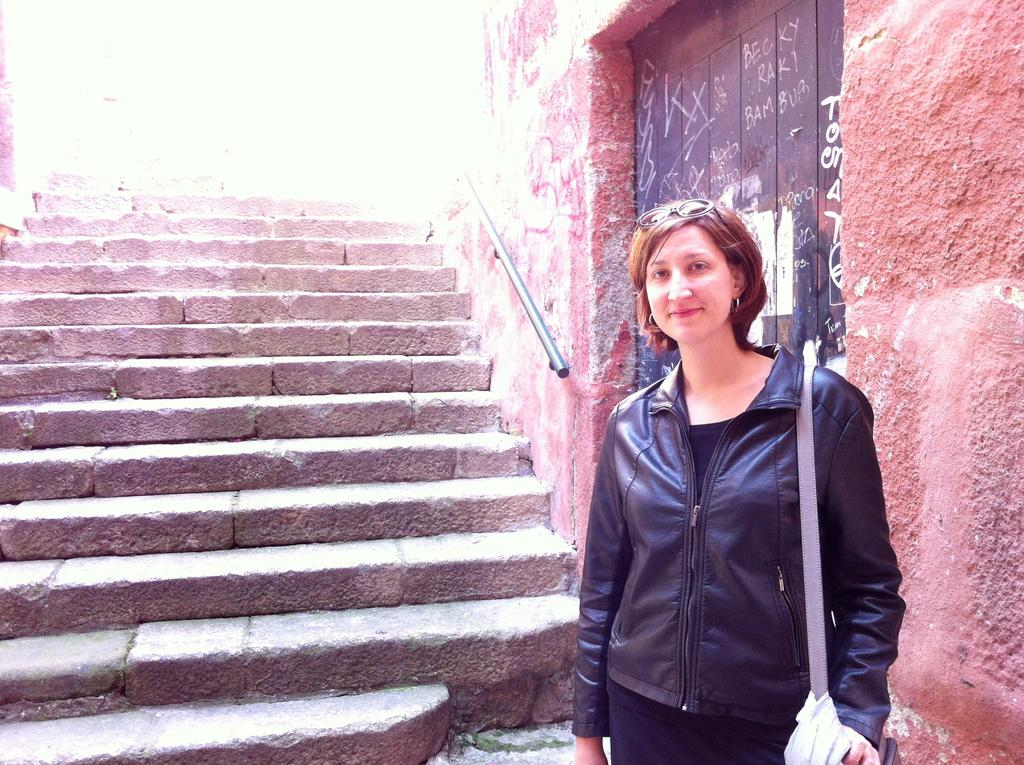Who is the main subject in the image? There is a woman in the image. What is the woman wearing? The woman is wearing a jacket. What is the woman carrying in the image? The woman is carrying a bag. What is the woman's expression in the image? The woman is standing and smiling. What architectural feature can be seen in the image? There are steps in the image. What is visible in the background of the image? There is a wall visible in the background of the image. How many horses are visible in the image? There are no horses present in the image. What type of flesh can be seen on the woman's face in the image? There is no mention of flesh or any specific facial features in the provided facts, and the image does not show any details that would allow us to describe the woman's face in such a way. 